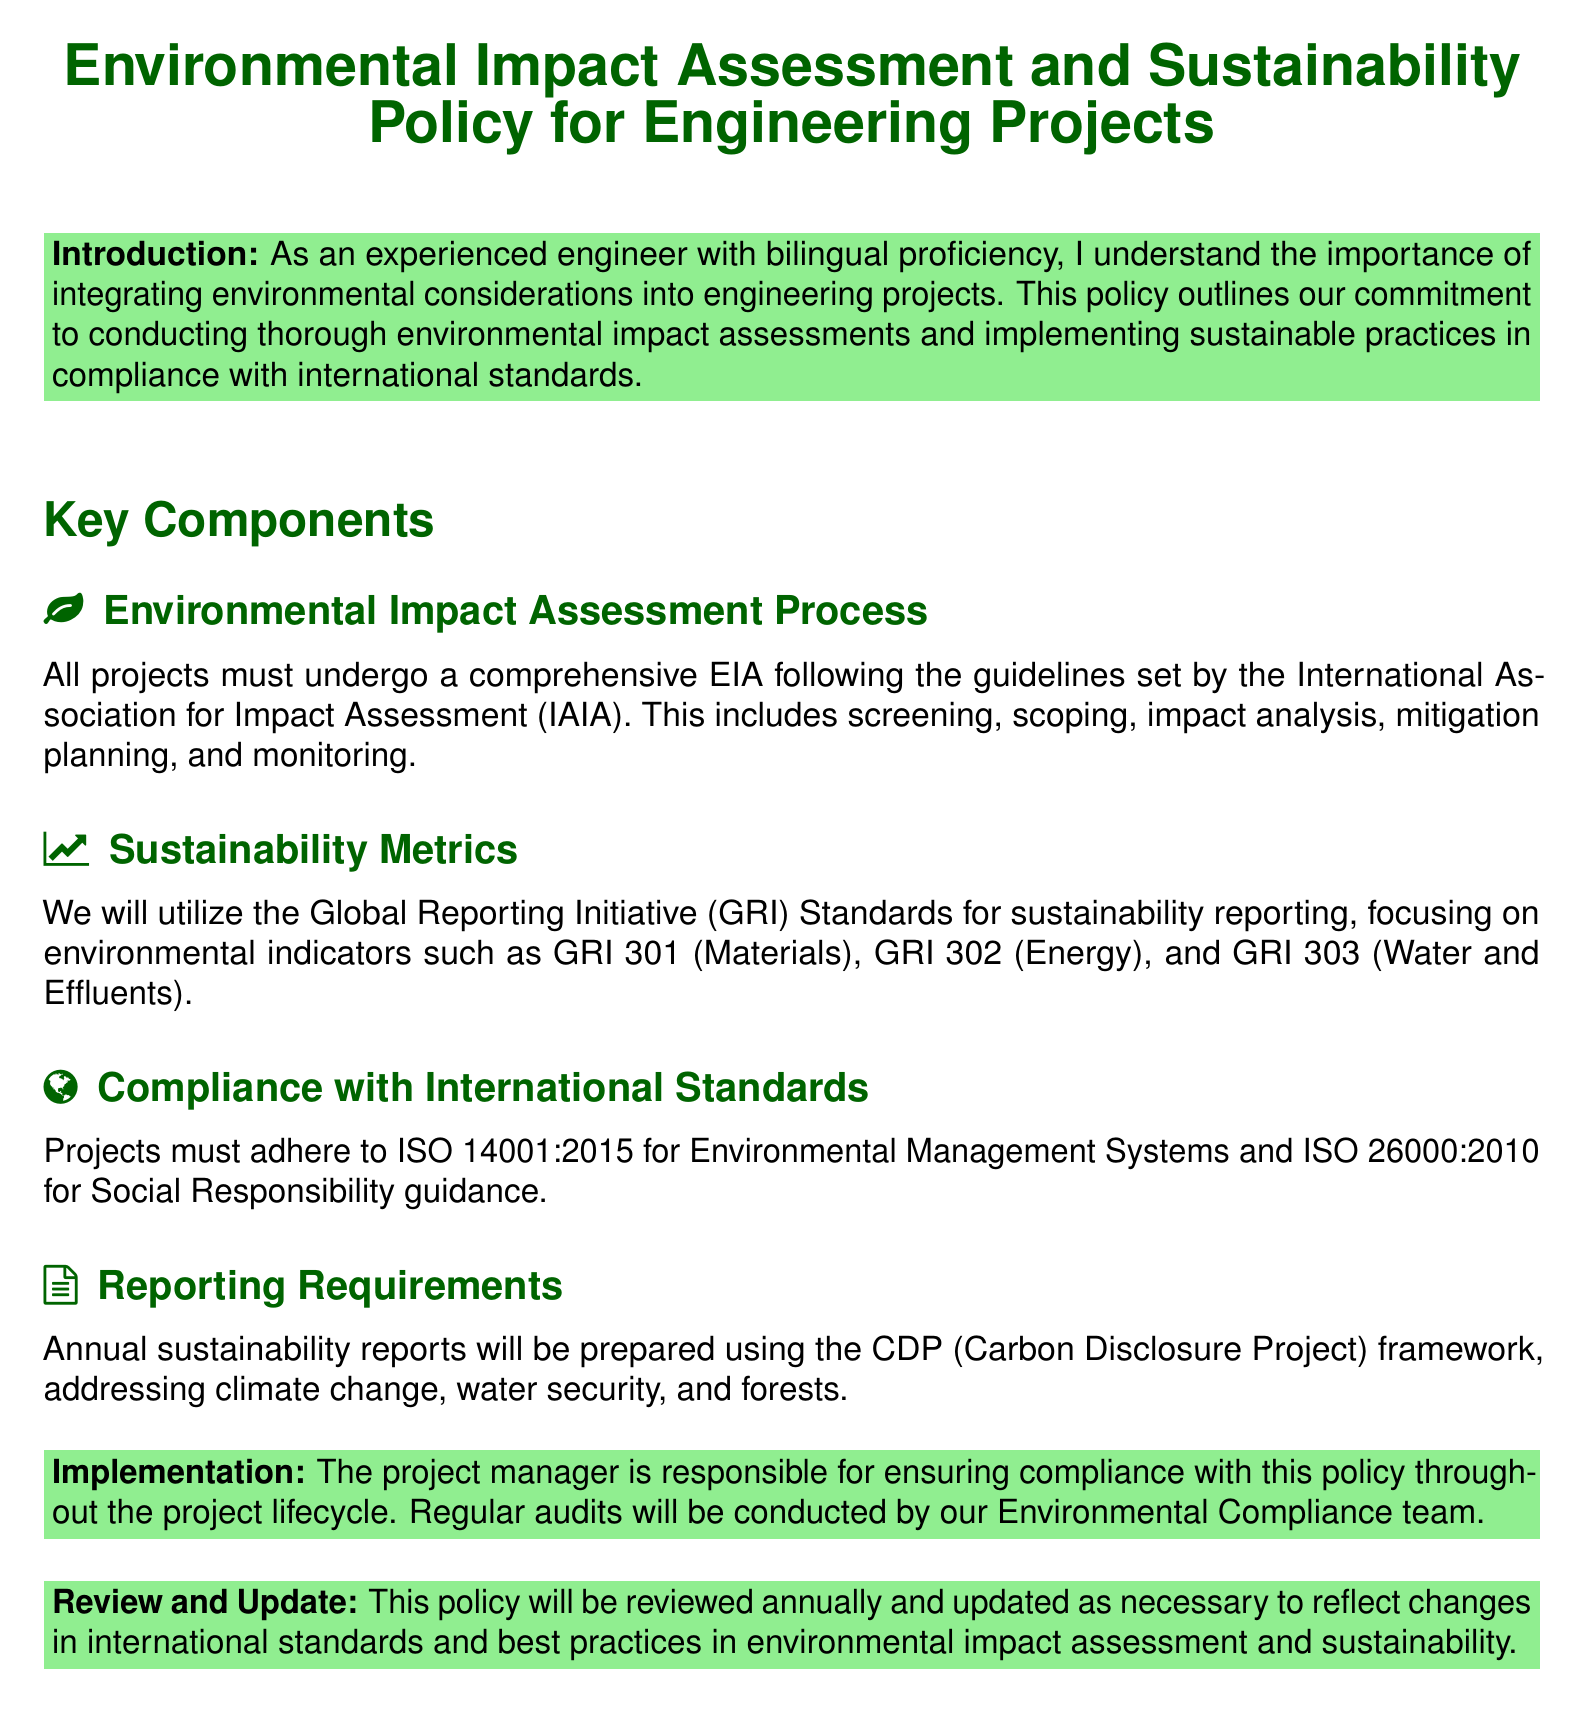What organization sets the guidelines for the Environmental Impact Assessment process? The document states that the guidelines for the Environmental Impact Assessment process are set by the International Association for Impact Assessment.
Answer: International Association for Impact Assessment Which sustainability reporting standards will be utilized? The document mentions that the Global Reporting Initiative Standards will be used for sustainability reporting.
Answer: Global Reporting Initiative Standards What is the ISO standard referenced for Environmental Management Systems? The policy refers to ISO 14001:2015 as the standard for Environmental Management Systems.
Answer: ISO 14001:2015 Who is responsible for ensuring compliance with the policy? According to the document, the project manager is responsible for ensuring compliance with the policy throughout the project lifecycle.
Answer: Project manager How often will the policy be reviewed? The document states that this policy will be reviewed annually.
Answer: Annually What framework will be used for annual sustainability reports? The policy indicates that the CDP (Carbon Disclosure Project) framework will be used for annual sustainability reports.
Answer: CDP (Carbon Disclosure Project) What type of metrics will be reported according to sustainability standards? The document specifies that environmental indicators will be reported, including materials, energy, and water.
Answer: Environmental indicators Which ISO standard is mentioned for Social Responsibility guidance? The document mentions ISO 26000:2010 for Social Responsibility guidance.
Answer: ISO 26000:2010 